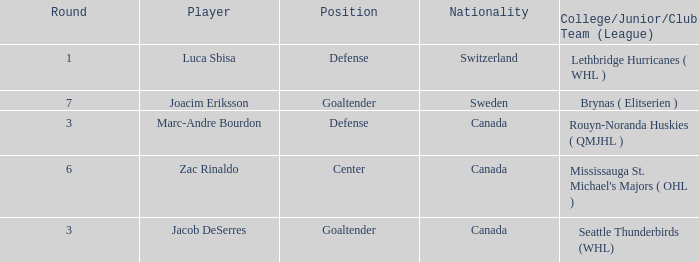What position did Luca Sbisa play for the Philadelphia Flyers? Defense. 